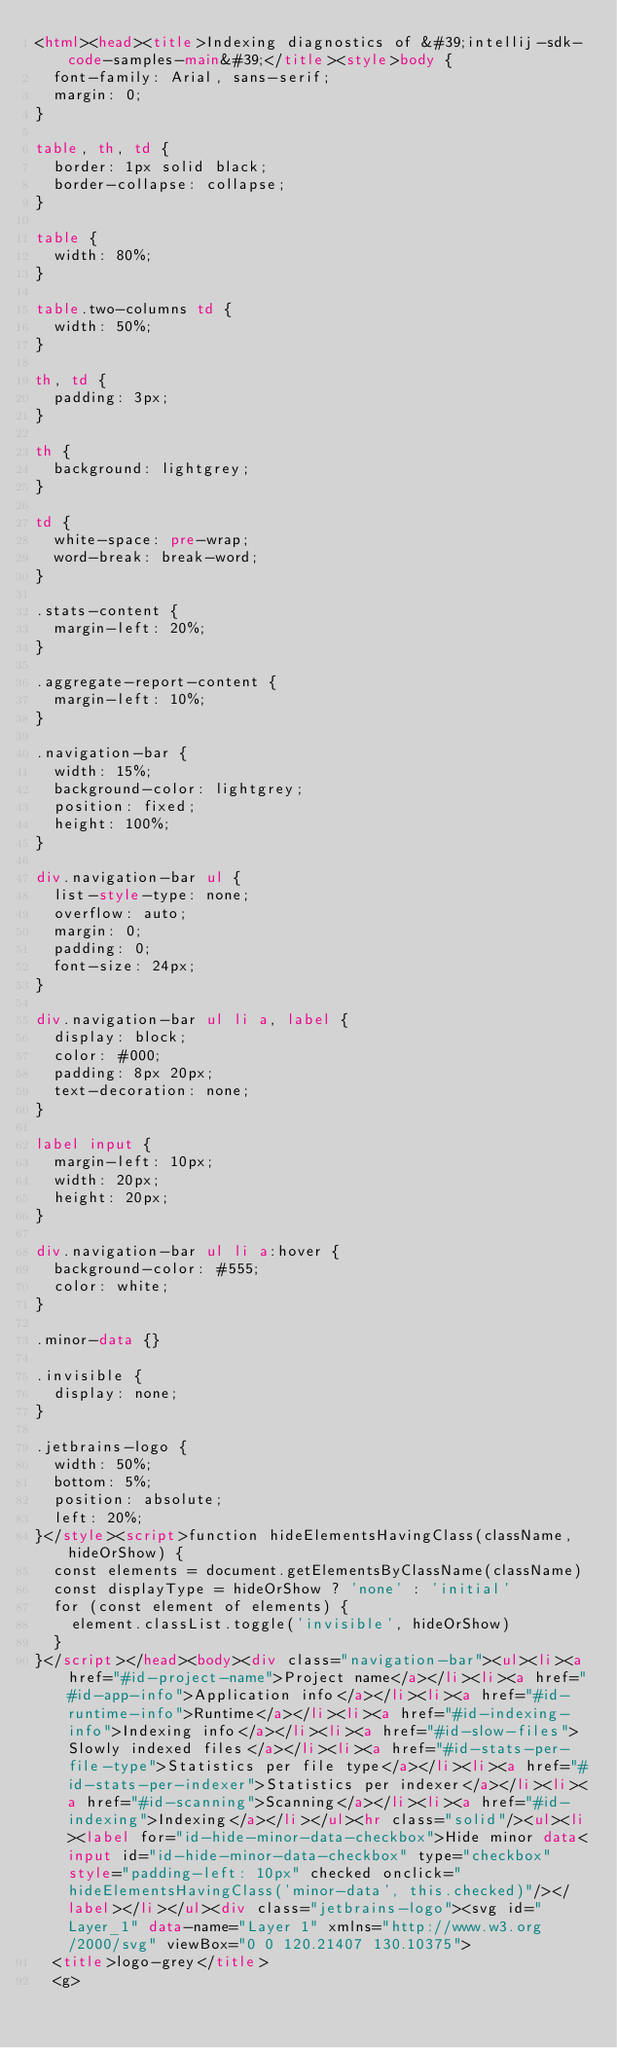<code> <loc_0><loc_0><loc_500><loc_500><_HTML_><html><head><title>Indexing diagnostics of &#39;intellij-sdk-code-samples-main&#39;</title><style>body {
  font-family: Arial, sans-serif;
  margin: 0;
}

table, th, td {
  border: 1px solid black;
  border-collapse: collapse;
}

table {
  width: 80%;
}

table.two-columns td {
  width: 50%;
}

th, td {
  padding: 3px;
}

th {
  background: lightgrey;
}

td {
  white-space: pre-wrap;
  word-break: break-word;
}
        
.stats-content {
  margin-left: 20%;
}

.aggregate-report-content {
  margin-left: 10%;
}

.navigation-bar {
  width: 15%;
  background-color: lightgrey;
  position: fixed;
  height: 100%;
}

div.navigation-bar ul {
  list-style-type: none;
  overflow: auto;
  margin: 0;
  padding: 0;
  font-size: 24px;
}

div.navigation-bar ul li a, label {
  display: block;
  color: #000;
  padding: 8px 20px;
  text-decoration: none;
}

label input {
  margin-left: 10px;
  width: 20px;
  height: 20px;
}

div.navigation-bar ul li a:hover {
  background-color: #555;
  color: white;
}

.minor-data {}

.invisible {
  display: none;
}

.jetbrains-logo {
  width: 50%;
  bottom: 5%;
  position: absolute;
  left: 20%;
}</style><script>function hideElementsHavingClass(className, hideOrShow) {
  const elements = document.getElementsByClassName(className)
  const displayType = hideOrShow ? 'none' : 'initial'
  for (const element of elements) {
    element.classList.toggle('invisible', hideOrShow)
  }
}</script></head><body><div class="navigation-bar"><ul><li><a href="#id-project-name">Project name</a></li><li><a href="#id-app-info">Application info</a></li><li><a href="#id-runtime-info">Runtime</a></li><li><a href="#id-indexing-info">Indexing info</a></li><li><a href="#id-slow-files">Slowly indexed files</a></li><li><a href="#id-stats-per-file-type">Statistics per file type</a></li><li><a href="#id-stats-per-indexer">Statistics per indexer</a></li><li><a href="#id-scanning">Scanning</a></li><li><a href="#id-indexing">Indexing</a></li></ul><hr class="solid"/><ul><li><label for="id-hide-minor-data-checkbox">Hide minor data<input id="id-hide-minor-data-checkbox" type="checkbox" style="padding-left: 10px" checked onclick="hideElementsHavingClass('minor-data', this.checked)"/></label></li></ul><div class="jetbrains-logo"><svg id="Layer_1" data-name="Layer 1" xmlns="http://www.w3.org/2000/svg" viewBox="0 0 120.21407 130.10375">
  <title>logo-grey</title>
  <g></code> 